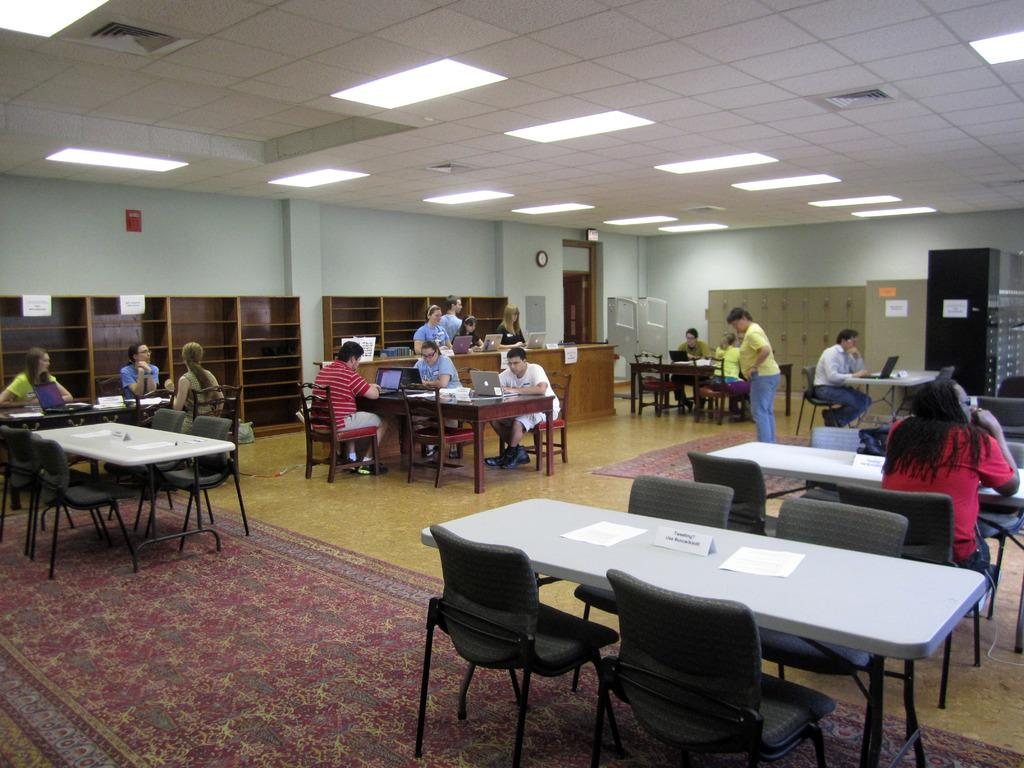What is happening in the image? There is a group of people in the image, and they are operating laptops. Can you describe the activity the people are engaged in? The people are using their laptops, which suggests they might be working, studying, or collaborating on a project. What type of rat can be seen climbing on the laptop in the image? There is no rat present in the image; it only shows a group of people operating laptops. 